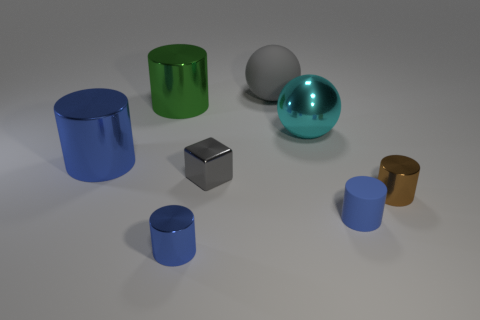What number of other objects are the same shape as the blue rubber thing?
Provide a succinct answer. 4. What material is the small blue cylinder to the left of the gray object that is behind the green metal thing?
Give a very brief answer. Metal. What shape is the big object that is the same color as the tiny block?
Offer a very short reply. Sphere. Are there any blue objects that have the same material as the gray sphere?
Give a very brief answer. Yes. There is a blue matte thing; what shape is it?
Your answer should be very brief. Cylinder. How many cyan cylinders are there?
Keep it short and to the point. 0. What color is the big object to the right of the rubber object behind the big blue shiny thing?
Your response must be concise. Cyan. The ball that is the same size as the cyan thing is what color?
Provide a succinct answer. Gray. Are there any large shiny spheres of the same color as the metal cube?
Make the answer very short. No. Are there any blue matte cylinders?
Your response must be concise. Yes. 